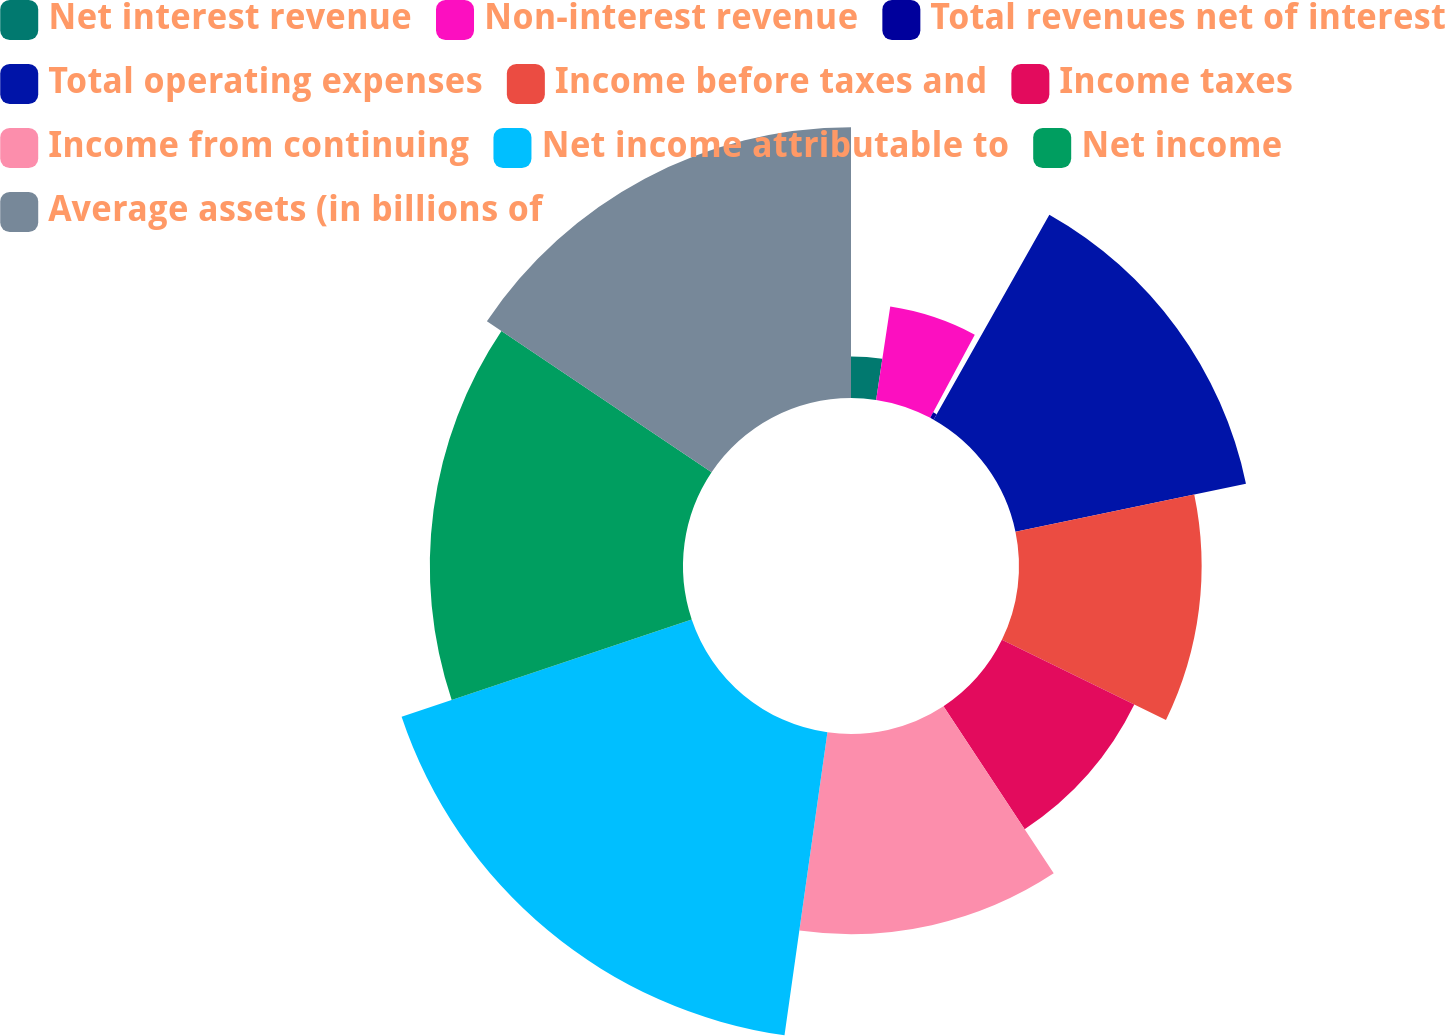<chart> <loc_0><loc_0><loc_500><loc_500><pie_chart><fcel>Net interest revenue<fcel>Non-interest revenue<fcel>Total revenues net of interest<fcel>Total operating expenses<fcel>Income before taxes and<fcel>Income taxes<fcel>Income from continuing<fcel>Net income attributable to<fcel>Net income<fcel>Average assets (in billions of<nl><fcel>2.39%<fcel>5.43%<fcel>0.36%<fcel>13.55%<fcel>10.51%<fcel>8.48%<fcel>11.52%<fcel>17.61%<fcel>14.57%<fcel>15.58%<nl></chart> 